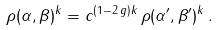Convert formula to latex. <formula><loc_0><loc_0><loc_500><loc_500>\rho ( \alpha , \beta ) ^ { k } = c ^ { ( 1 - 2 \, g ) k } \, \rho ( \alpha ^ { \prime } , \beta ^ { \prime } ) ^ { k } \, .</formula> 